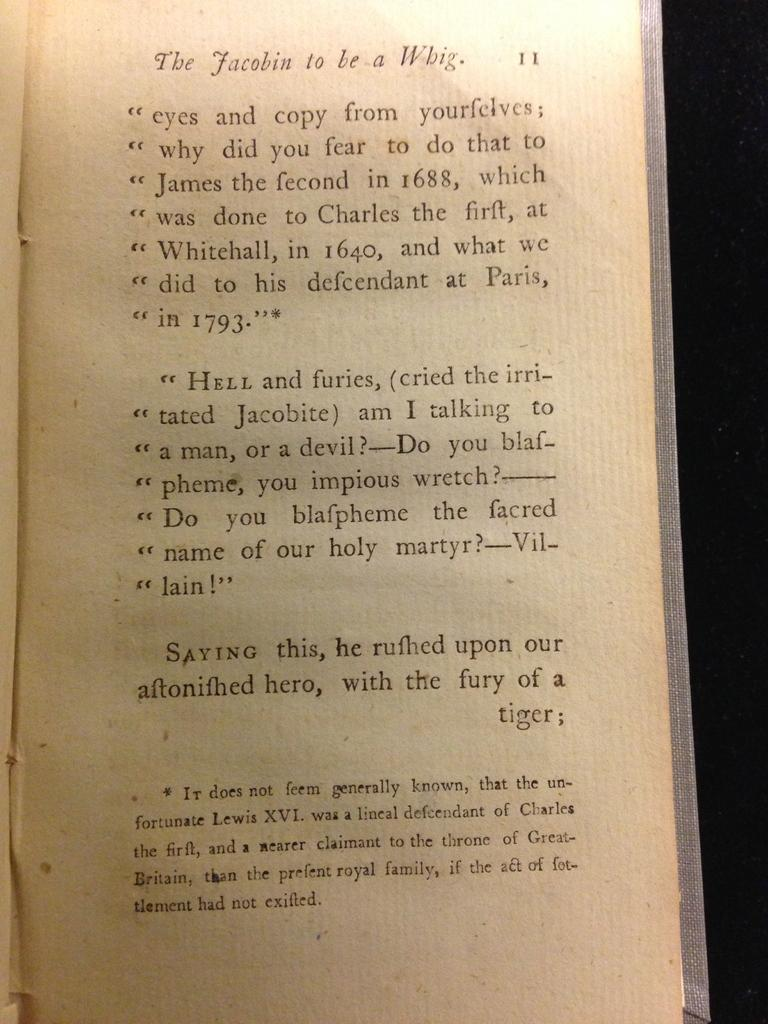<image>
Give a short and clear explanation of the subsequent image. A page from the book "The Jacobin to be a Whig" 